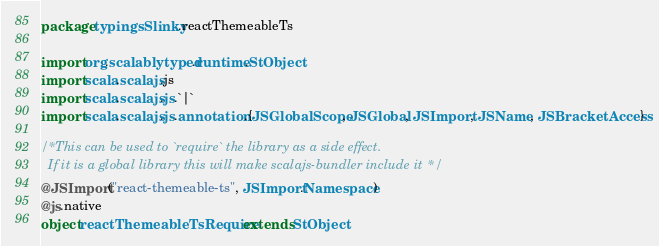<code> <loc_0><loc_0><loc_500><loc_500><_Scala_>package typingsSlinky.reactThemeableTs

import org.scalablytyped.runtime.StObject
import scala.scalajs.js
import scala.scalajs.js.`|`
import scala.scalajs.js.annotation.{JSGlobalScope, JSGlobal, JSImport, JSName, JSBracketAccess}

/* This can be used to `require` the library as a side effect.
  If it is a global library this will make scalajs-bundler include it */
@JSImport("react-themeable-ts", JSImport.Namespace)
@js.native
object reactThemeableTsRequire extends StObject
</code> 